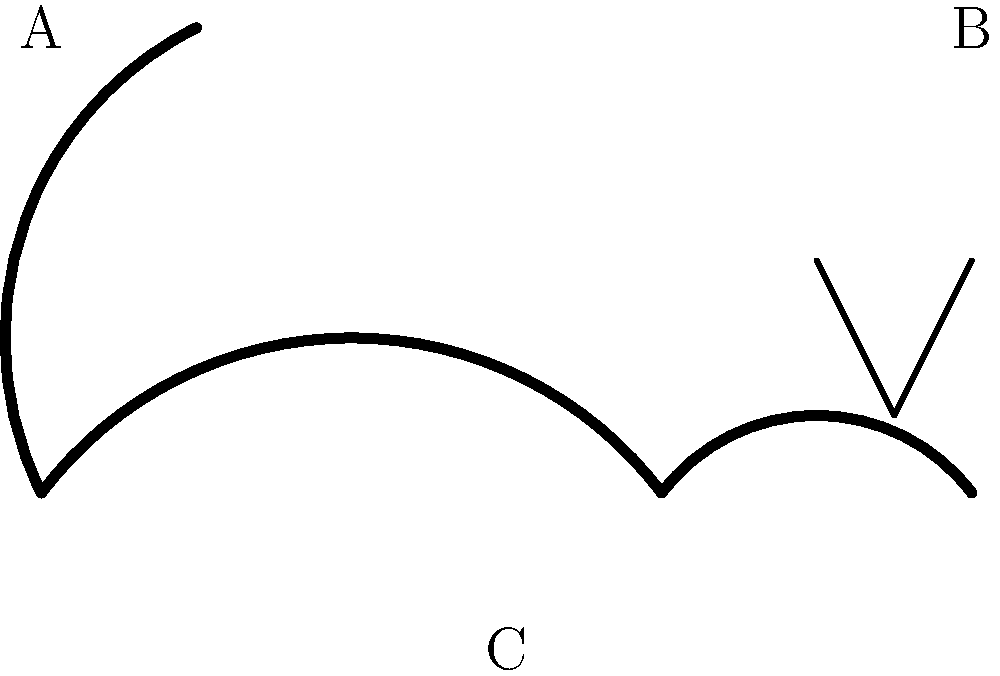As a dog walker, you notice a dog exhibiting the body language shown in the diagram. Which part of the dog's body, labeled A, B, or C, is most crucial in determining the dog's emotional state in this instance, and what is the likely emotion being expressed? To interpret the dog's body language and emotional state, we need to analyze each labeled part:

1. Part A (Tail): The tail is raised and curved, indicating alertness or excitement.
2. Part B (Ears): The ears are perked up and forward, suggesting attentiveness or interest.
3. Part C (Body posture): The body appears relaxed and neutral.

Step-by-step analysis:
1. While all parts of a dog's body contribute to its overall body language, the tail (A) is often the most expressive and easiest to interpret.
2. A raised, curved tail typically indicates a positive emotional state.
3. The perked ears (B) support this interpretation, showing the dog is alert and interested in its surroundings.
4. The relaxed body posture (C) further confirms that the dog is not in a state of stress or aggression.

Considering all these factors, the tail (A) is the most crucial in determining the dog's emotional state in this instance. The raised, curved tail strongly suggests that the dog is feeling happy, excited, or friendly.
Answer: A (tail); happy or excited 